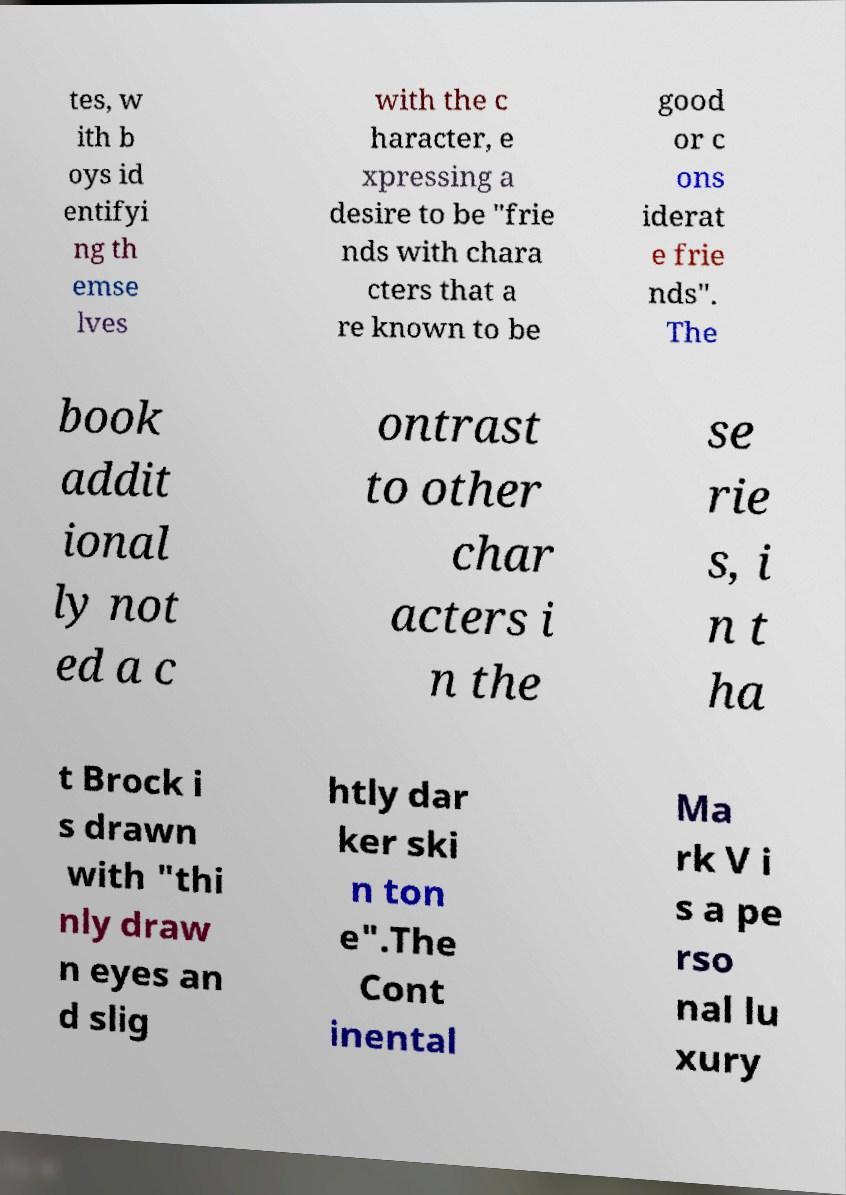Please read and relay the text visible in this image. What does it say? tes, w ith b oys id entifyi ng th emse lves with the c haracter, e xpressing a desire to be "frie nds with chara cters that a re known to be good or c ons iderat e frie nds". The book addit ional ly not ed a c ontrast to other char acters i n the se rie s, i n t ha t Brock i s drawn with "thi nly draw n eyes an d slig htly dar ker ski n ton e".The Cont inental Ma rk V i s a pe rso nal lu xury 